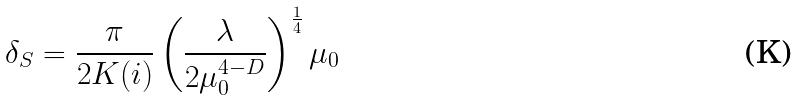Convert formula to latex. <formula><loc_0><loc_0><loc_500><loc_500>\delta _ { S } = \frac { \pi } { 2 K ( i ) } \left ( \frac { \lambda } { 2 \mu _ { 0 } ^ { 4 - D } } \right ) ^ { \frac { 1 } { 4 } } \mu _ { 0 }</formula> 